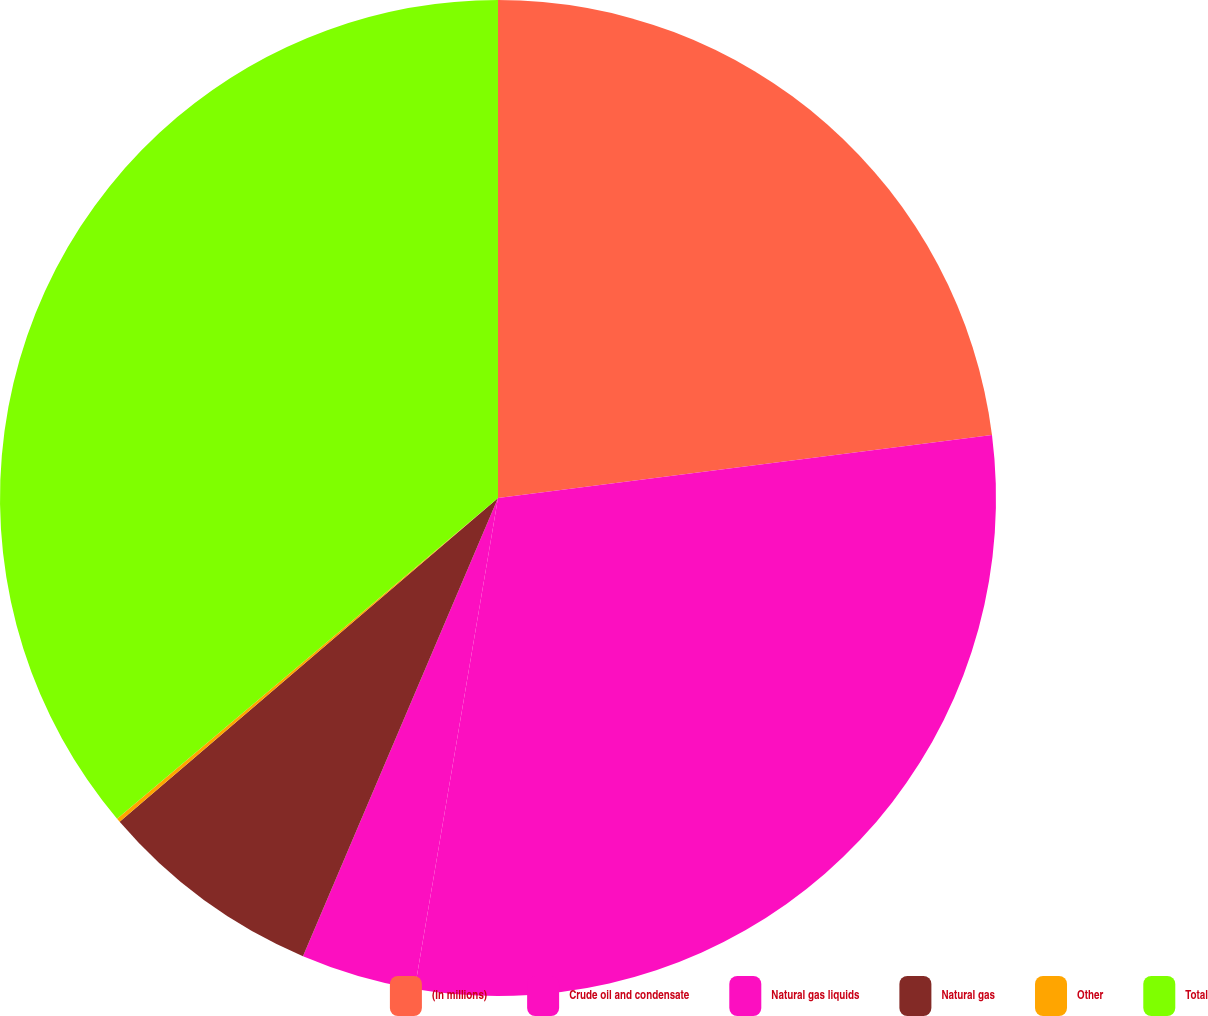Convert chart. <chart><loc_0><loc_0><loc_500><loc_500><pie_chart><fcel>(In millions)<fcel>Crude oil and condensate<fcel>Natural gas liquids<fcel>Natural gas<fcel>Other<fcel>Total<nl><fcel>22.98%<fcel>29.7%<fcel>3.73%<fcel>7.33%<fcel>0.13%<fcel>36.14%<nl></chart> 